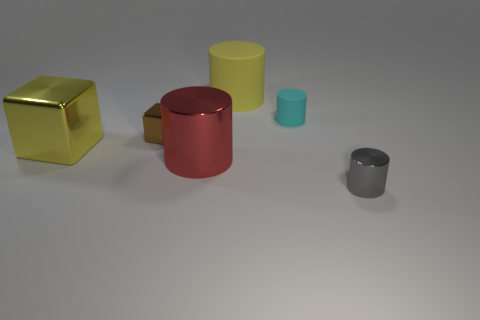What shape is the tiny rubber object right of the big thing that is behind the small metallic object that is behind the big yellow shiny cube?
Give a very brief answer. Cylinder. Are there the same number of metallic objects that are in front of the brown metal block and big blue blocks?
Your answer should be very brief. No. Do the brown metal object and the gray metallic cylinder have the same size?
Give a very brief answer. Yes. What number of shiny things are either large purple objects or cylinders?
Your answer should be compact. 2. What material is the other yellow thing that is the same size as the yellow rubber thing?
Offer a very short reply. Metal. What number of other things are made of the same material as the gray cylinder?
Provide a succinct answer. 3. Is the number of things that are behind the red cylinder less than the number of large yellow cylinders?
Ensure brevity in your answer.  No. Does the small cyan thing have the same shape as the small gray metal object?
Provide a short and direct response. Yes. How big is the block left of the metallic object behind the large yellow object on the left side of the large rubber thing?
Keep it short and to the point. Large. There is a yellow thing that is the same shape as the gray metallic thing; what is it made of?
Provide a short and direct response. Rubber. 